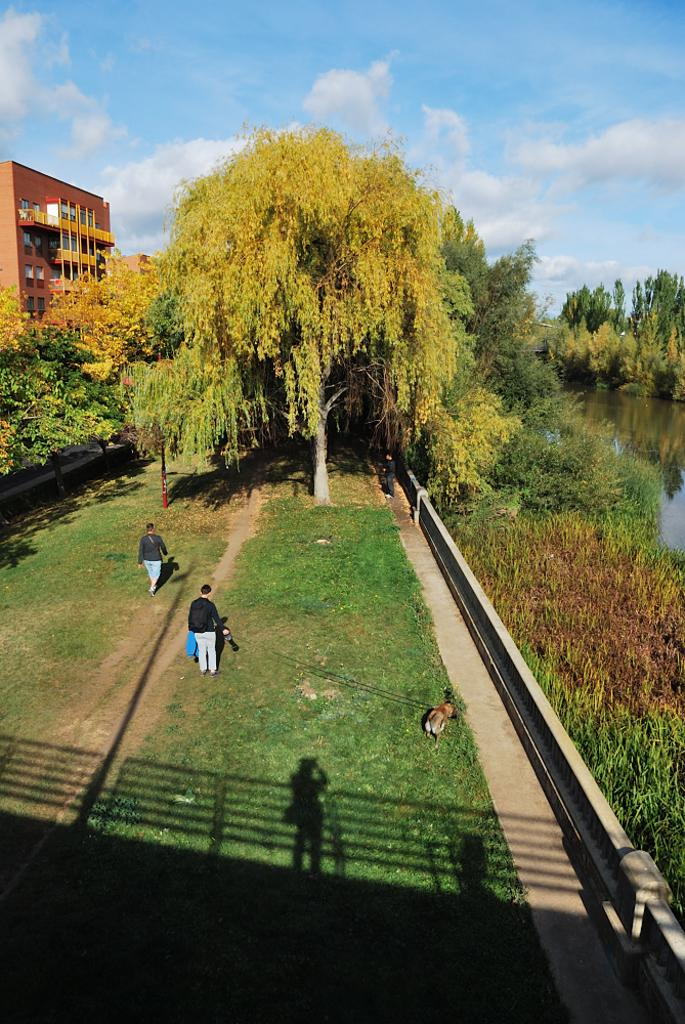Who or what can be seen in the image? There are people in the image. What type of terrain is visible in the image? There is grass in the image. What other living creature is present in the image? There is an animal in the image. What can be seen in the distance in the image? There are trees, a building, and clouds in the background of the image. What is visible on the right side of the image? There is water visible on the right side of the image. What type of snow can be seen on the toes of the people in the image? There is no snow present in the image, and no mention of toes. 